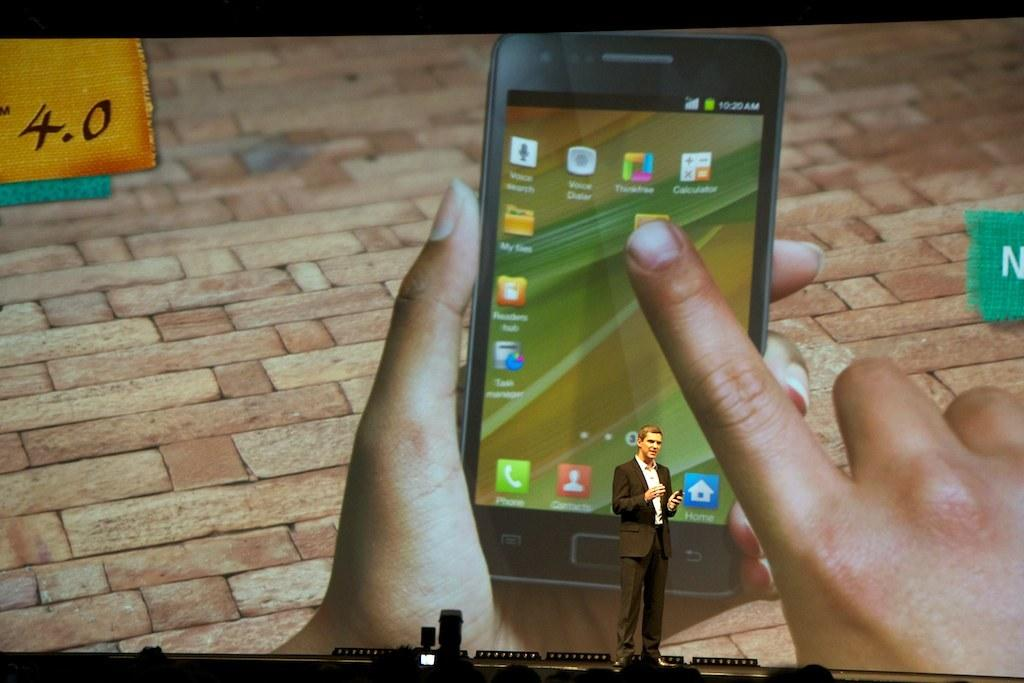<image>
Describe the image concisely. A women holding a smart phone on a picture with 4.0 written in the left top corner. 